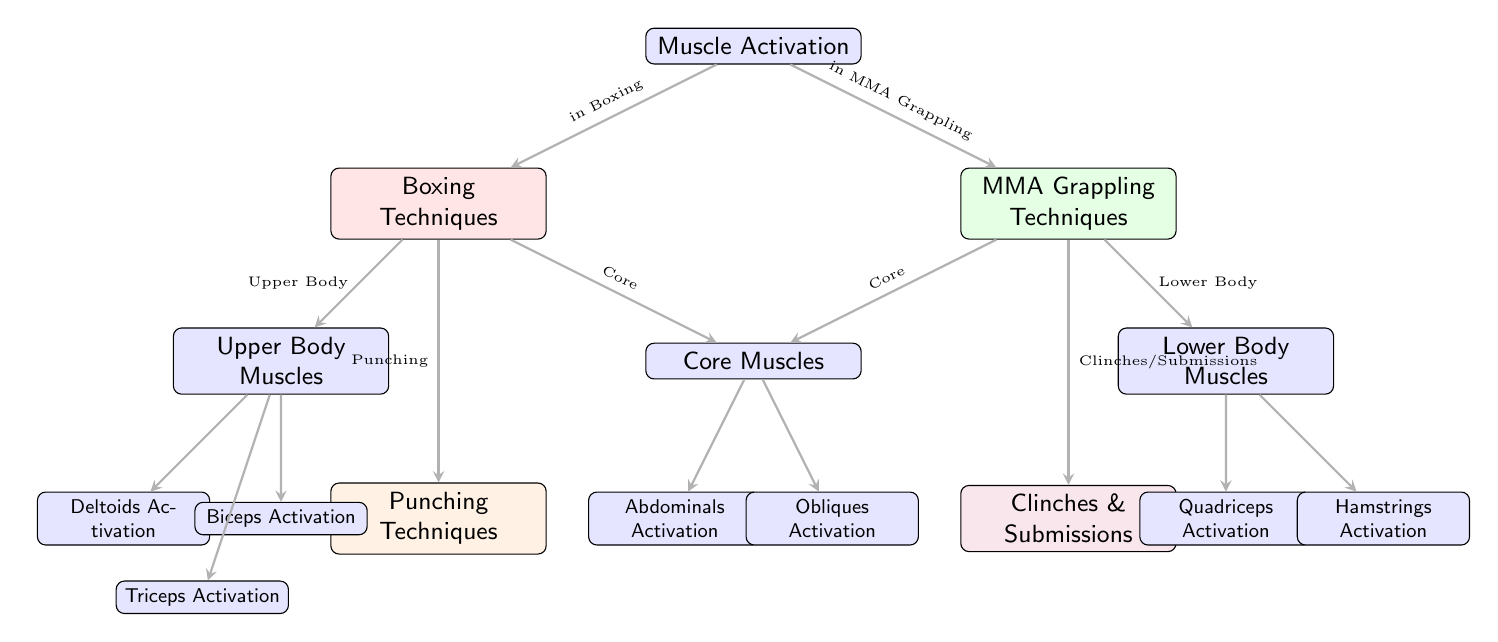What type of techniques are represented for boxing? The diagram specifies that for boxing, the techniques represented are "Punching Techniques." This is identified in the node connected to "Boxing Techniques," indicating the primary action involved.
Answer: Punching Techniques How many types of muscle activation are shown in the diagram? The diagram features three distinct types of muscle activation: Upper Body Muscles, Core Muscles, and Lower Body Muscles, which are clearly labeled in their respective nodes.
Answer: Three Which muscle group is associated with MMA grappling techniques? The diagram shows that MMA grappling techniques are associated with "Lower Body Muscles," which is indicated by the connection from the "MMA" node to the "Lower Body Muscles" node.
Answer: Lower Body Muscles How many types of muscle activation are shown under boxing techniques? In the diagram for boxing techniques, there are three types of muscle activation listed under Upper Body Muscles: Deltoids, Biceps, and Triceps, connected directly to the Upper node.
Answer: Three What is the relationship between core muscles and both boxing and MMA? The diagram illustrates that "Core Muscles" are activated in both boxing and MMA. This is depicted by the connections from both the "Boxing" and "MMA" nodes leading to the "Core Muscles" node, indicating that core activation is relevant in both contexts.
Answer: In both Which muscle activation is directly linked to clinches and submissions in MMA? The diagram indicates that "Clinches & Submissions" are associated specifically with "Lower Body Muscles," as shown by the direct connection from the "MMA" node to the "Clinches & Submissions" node and further to the Lower Body functionality.
Answer: Lower Body Muscles Which upper body muscles are activated during boxing techniques? The upper body muscles activated during boxing techniques, as depicted in the diagram, are Deltoids, Biceps, and Triceps, all connected to the "Upper Body Muscles" node.
Answer: Deltoids, Biceps, Triceps What type of muscle activation do both sports require for abdominal work? The diagram shows that both boxing and MMA require "Abdominals Activation," highlighting the role of core strength in the performance of techniques from both disciplines.
Answer: Abdominals Activation 